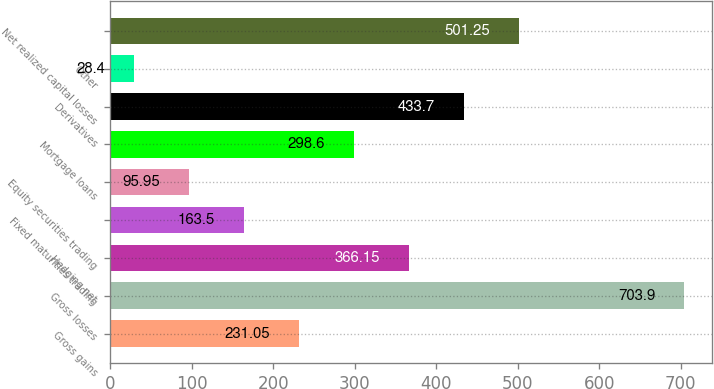<chart> <loc_0><loc_0><loc_500><loc_500><bar_chart><fcel>Gross gains<fcel>Gross losses<fcel>Hedging net<fcel>Fixed maturities trading<fcel>Equity securities trading<fcel>Mortgage loans<fcel>Derivatives<fcel>Other<fcel>Net realized capital losses<nl><fcel>231.05<fcel>703.9<fcel>366.15<fcel>163.5<fcel>95.95<fcel>298.6<fcel>433.7<fcel>28.4<fcel>501.25<nl></chart> 